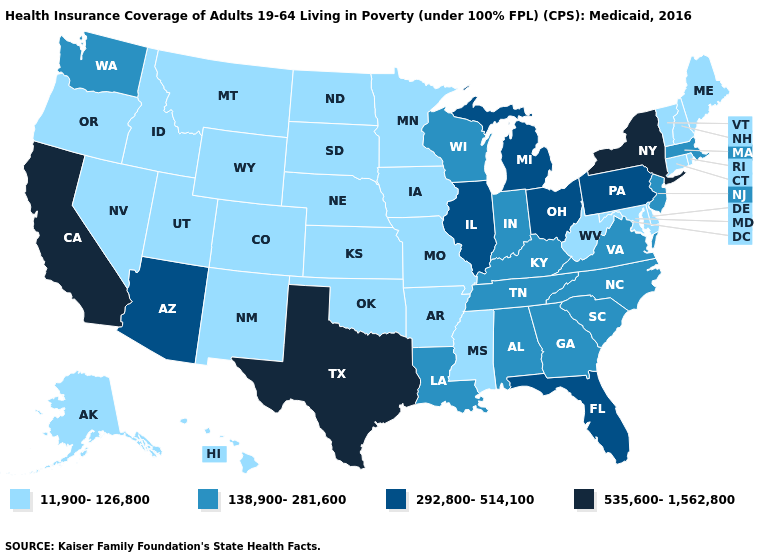How many symbols are there in the legend?
Quick response, please. 4. What is the value of Oklahoma?
Keep it brief. 11,900-126,800. Name the states that have a value in the range 138,900-281,600?
Concise answer only. Alabama, Georgia, Indiana, Kentucky, Louisiana, Massachusetts, New Jersey, North Carolina, South Carolina, Tennessee, Virginia, Washington, Wisconsin. Which states have the lowest value in the USA?
Give a very brief answer. Alaska, Arkansas, Colorado, Connecticut, Delaware, Hawaii, Idaho, Iowa, Kansas, Maine, Maryland, Minnesota, Mississippi, Missouri, Montana, Nebraska, Nevada, New Hampshire, New Mexico, North Dakota, Oklahoma, Oregon, Rhode Island, South Dakota, Utah, Vermont, West Virginia, Wyoming. Name the states that have a value in the range 138,900-281,600?
Answer briefly. Alabama, Georgia, Indiana, Kentucky, Louisiana, Massachusetts, New Jersey, North Carolina, South Carolina, Tennessee, Virginia, Washington, Wisconsin. Which states have the highest value in the USA?
Give a very brief answer. California, New York, Texas. What is the highest value in the Northeast ?
Quick response, please. 535,600-1,562,800. Name the states that have a value in the range 138,900-281,600?
Keep it brief. Alabama, Georgia, Indiana, Kentucky, Louisiana, Massachusetts, New Jersey, North Carolina, South Carolina, Tennessee, Virginia, Washington, Wisconsin. Among the states that border Montana , which have the highest value?
Write a very short answer. Idaho, North Dakota, South Dakota, Wyoming. What is the value of New York?
Short answer required. 535,600-1,562,800. Name the states that have a value in the range 535,600-1,562,800?
Answer briefly. California, New York, Texas. What is the value of Utah?
Answer briefly. 11,900-126,800. What is the highest value in the USA?
Short answer required. 535,600-1,562,800. Is the legend a continuous bar?
Quick response, please. No. What is the lowest value in the USA?
Concise answer only. 11,900-126,800. 